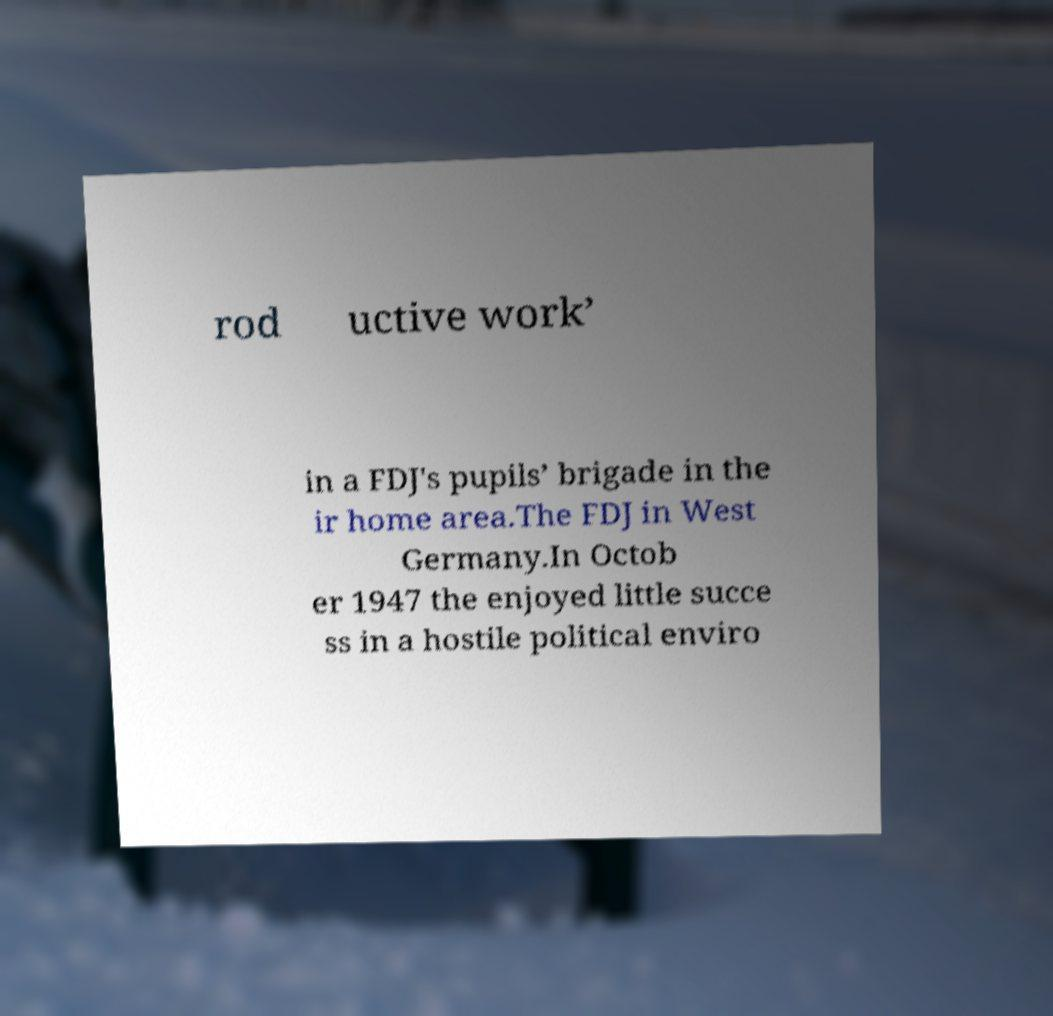Could you assist in decoding the text presented in this image and type it out clearly? rod uctive work’ in a FDJ's pupils’ brigade in the ir home area.The FDJ in West Germany.In Octob er 1947 the enjoyed little succe ss in a hostile political enviro 